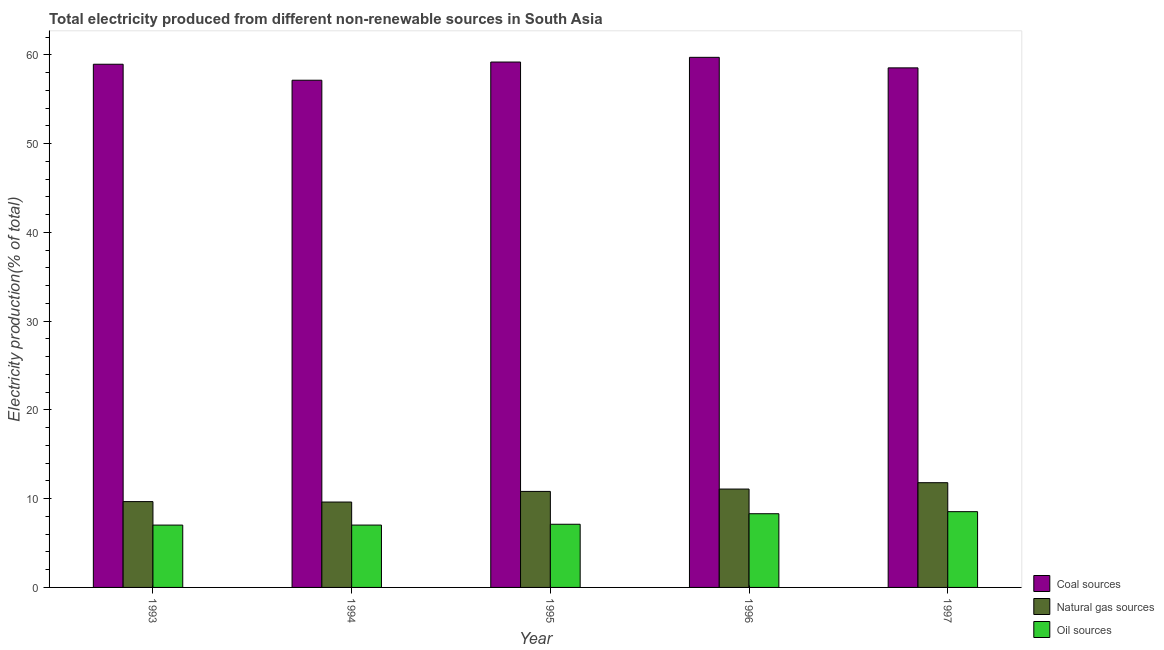Are the number of bars per tick equal to the number of legend labels?
Give a very brief answer. Yes. Are the number of bars on each tick of the X-axis equal?
Your answer should be compact. Yes. What is the label of the 3rd group of bars from the left?
Make the answer very short. 1995. In how many cases, is the number of bars for a given year not equal to the number of legend labels?
Make the answer very short. 0. What is the percentage of electricity produced by natural gas in 1996?
Your answer should be compact. 11.08. Across all years, what is the maximum percentage of electricity produced by coal?
Your answer should be compact. 59.73. Across all years, what is the minimum percentage of electricity produced by natural gas?
Ensure brevity in your answer.  9.62. In which year was the percentage of electricity produced by oil sources maximum?
Ensure brevity in your answer.  1997. What is the total percentage of electricity produced by natural gas in the graph?
Ensure brevity in your answer.  53. What is the difference between the percentage of electricity produced by natural gas in 1993 and that in 1995?
Provide a succinct answer. -1.15. What is the difference between the percentage of electricity produced by natural gas in 1996 and the percentage of electricity produced by coal in 1993?
Your answer should be very brief. 1.41. What is the average percentage of electricity produced by oil sources per year?
Offer a very short reply. 7.6. In how many years, is the percentage of electricity produced by oil sources greater than 44 %?
Your answer should be very brief. 0. What is the ratio of the percentage of electricity produced by oil sources in 1995 to that in 1997?
Give a very brief answer. 0.83. Is the percentage of electricity produced by coal in 1994 less than that in 1997?
Provide a succinct answer. Yes. What is the difference between the highest and the second highest percentage of electricity produced by coal?
Make the answer very short. 0.53. What is the difference between the highest and the lowest percentage of electricity produced by coal?
Make the answer very short. 2.58. Is the sum of the percentage of electricity produced by coal in 1994 and 1995 greater than the maximum percentage of electricity produced by natural gas across all years?
Your response must be concise. Yes. What does the 3rd bar from the left in 1997 represents?
Give a very brief answer. Oil sources. What does the 2nd bar from the right in 1994 represents?
Ensure brevity in your answer.  Natural gas sources. Is it the case that in every year, the sum of the percentage of electricity produced by coal and percentage of electricity produced by natural gas is greater than the percentage of electricity produced by oil sources?
Offer a very short reply. Yes. How many bars are there?
Your response must be concise. 15. Does the graph contain any zero values?
Give a very brief answer. No. Where does the legend appear in the graph?
Your answer should be compact. Bottom right. What is the title of the graph?
Your response must be concise. Total electricity produced from different non-renewable sources in South Asia. What is the label or title of the X-axis?
Offer a terse response. Year. What is the label or title of the Y-axis?
Provide a succinct answer. Electricity production(% of total). What is the Electricity production(% of total) in Coal sources in 1993?
Offer a very short reply. 58.95. What is the Electricity production(% of total) in Natural gas sources in 1993?
Keep it short and to the point. 9.67. What is the Electricity production(% of total) of Oil sources in 1993?
Your answer should be compact. 7.02. What is the Electricity production(% of total) of Coal sources in 1994?
Make the answer very short. 57.15. What is the Electricity production(% of total) of Natural gas sources in 1994?
Your answer should be very brief. 9.62. What is the Electricity production(% of total) in Oil sources in 1994?
Your response must be concise. 7.03. What is the Electricity production(% of total) of Coal sources in 1995?
Offer a terse response. 59.2. What is the Electricity production(% of total) in Natural gas sources in 1995?
Provide a short and direct response. 10.82. What is the Electricity production(% of total) of Oil sources in 1995?
Provide a succinct answer. 7.12. What is the Electricity production(% of total) of Coal sources in 1996?
Make the answer very short. 59.73. What is the Electricity production(% of total) of Natural gas sources in 1996?
Keep it short and to the point. 11.08. What is the Electricity production(% of total) of Oil sources in 1996?
Your answer should be compact. 8.3. What is the Electricity production(% of total) in Coal sources in 1997?
Your response must be concise. 58.55. What is the Electricity production(% of total) of Natural gas sources in 1997?
Your answer should be very brief. 11.8. What is the Electricity production(% of total) in Oil sources in 1997?
Provide a succinct answer. 8.54. Across all years, what is the maximum Electricity production(% of total) in Coal sources?
Your response must be concise. 59.73. Across all years, what is the maximum Electricity production(% of total) of Natural gas sources?
Give a very brief answer. 11.8. Across all years, what is the maximum Electricity production(% of total) of Oil sources?
Ensure brevity in your answer.  8.54. Across all years, what is the minimum Electricity production(% of total) in Coal sources?
Make the answer very short. 57.15. Across all years, what is the minimum Electricity production(% of total) of Natural gas sources?
Make the answer very short. 9.62. Across all years, what is the minimum Electricity production(% of total) in Oil sources?
Provide a succinct answer. 7.02. What is the total Electricity production(% of total) of Coal sources in the graph?
Provide a short and direct response. 293.59. What is the total Electricity production(% of total) in Natural gas sources in the graph?
Make the answer very short. 53. What is the total Electricity production(% of total) of Oil sources in the graph?
Offer a very short reply. 38.01. What is the difference between the Electricity production(% of total) of Coal sources in 1993 and that in 1994?
Ensure brevity in your answer.  1.8. What is the difference between the Electricity production(% of total) in Natural gas sources in 1993 and that in 1994?
Give a very brief answer. 0.05. What is the difference between the Electricity production(% of total) in Oil sources in 1993 and that in 1994?
Provide a short and direct response. -0. What is the difference between the Electricity production(% of total) of Coal sources in 1993 and that in 1995?
Provide a short and direct response. -0.25. What is the difference between the Electricity production(% of total) of Natural gas sources in 1993 and that in 1995?
Make the answer very short. -1.15. What is the difference between the Electricity production(% of total) of Oil sources in 1993 and that in 1995?
Provide a succinct answer. -0.09. What is the difference between the Electricity production(% of total) of Coal sources in 1993 and that in 1996?
Your response must be concise. -0.78. What is the difference between the Electricity production(% of total) of Natural gas sources in 1993 and that in 1996?
Your response must be concise. -1.41. What is the difference between the Electricity production(% of total) of Oil sources in 1993 and that in 1996?
Your response must be concise. -1.28. What is the difference between the Electricity production(% of total) of Coal sources in 1993 and that in 1997?
Provide a short and direct response. 0.41. What is the difference between the Electricity production(% of total) of Natural gas sources in 1993 and that in 1997?
Keep it short and to the point. -2.13. What is the difference between the Electricity production(% of total) in Oil sources in 1993 and that in 1997?
Your answer should be very brief. -1.51. What is the difference between the Electricity production(% of total) of Coal sources in 1994 and that in 1995?
Your answer should be very brief. -2.05. What is the difference between the Electricity production(% of total) of Natural gas sources in 1994 and that in 1995?
Offer a very short reply. -1.2. What is the difference between the Electricity production(% of total) of Oil sources in 1994 and that in 1995?
Ensure brevity in your answer.  -0.09. What is the difference between the Electricity production(% of total) in Coal sources in 1994 and that in 1996?
Provide a succinct answer. -2.58. What is the difference between the Electricity production(% of total) of Natural gas sources in 1994 and that in 1996?
Ensure brevity in your answer.  -1.46. What is the difference between the Electricity production(% of total) in Oil sources in 1994 and that in 1996?
Ensure brevity in your answer.  -1.28. What is the difference between the Electricity production(% of total) in Coal sources in 1994 and that in 1997?
Offer a very short reply. -1.39. What is the difference between the Electricity production(% of total) in Natural gas sources in 1994 and that in 1997?
Make the answer very short. -2.18. What is the difference between the Electricity production(% of total) in Oil sources in 1994 and that in 1997?
Offer a terse response. -1.51. What is the difference between the Electricity production(% of total) of Coal sources in 1995 and that in 1996?
Give a very brief answer. -0.53. What is the difference between the Electricity production(% of total) of Natural gas sources in 1995 and that in 1996?
Give a very brief answer. -0.27. What is the difference between the Electricity production(% of total) in Oil sources in 1995 and that in 1996?
Give a very brief answer. -1.19. What is the difference between the Electricity production(% of total) of Coal sources in 1995 and that in 1997?
Offer a very short reply. 0.66. What is the difference between the Electricity production(% of total) in Natural gas sources in 1995 and that in 1997?
Offer a very short reply. -0.98. What is the difference between the Electricity production(% of total) in Oil sources in 1995 and that in 1997?
Keep it short and to the point. -1.42. What is the difference between the Electricity production(% of total) in Coal sources in 1996 and that in 1997?
Provide a short and direct response. 1.19. What is the difference between the Electricity production(% of total) of Natural gas sources in 1996 and that in 1997?
Offer a terse response. -0.72. What is the difference between the Electricity production(% of total) in Oil sources in 1996 and that in 1997?
Make the answer very short. -0.23. What is the difference between the Electricity production(% of total) of Coal sources in 1993 and the Electricity production(% of total) of Natural gas sources in 1994?
Your answer should be very brief. 49.33. What is the difference between the Electricity production(% of total) in Coal sources in 1993 and the Electricity production(% of total) in Oil sources in 1994?
Your response must be concise. 51.93. What is the difference between the Electricity production(% of total) in Natural gas sources in 1993 and the Electricity production(% of total) in Oil sources in 1994?
Offer a terse response. 2.64. What is the difference between the Electricity production(% of total) of Coal sources in 1993 and the Electricity production(% of total) of Natural gas sources in 1995?
Offer a very short reply. 48.14. What is the difference between the Electricity production(% of total) in Coal sources in 1993 and the Electricity production(% of total) in Oil sources in 1995?
Keep it short and to the point. 51.84. What is the difference between the Electricity production(% of total) in Natural gas sources in 1993 and the Electricity production(% of total) in Oil sources in 1995?
Offer a terse response. 2.55. What is the difference between the Electricity production(% of total) of Coal sources in 1993 and the Electricity production(% of total) of Natural gas sources in 1996?
Provide a succinct answer. 47.87. What is the difference between the Electricity production(% of total) in Coal sources in 1993 and the Electricity production(% of total) in Oil sources in 1996?
Your response must be concise. 50.65. What is the difference between the Electricity production(% of total) in Natural gas sources in 1993 and the Electricity production(% of total) in Oil sources in 1996?
Your response must be concise. 1.37. What is the difference between the Electricity production(% of total) in Coal sources in 1993 and the Electricity production(% of total) in Natural gas sources in 1997?
Ensure brevity in your answer.  47.15. What is the difference between the Electricity production(% of total) in Coal sources in 1993 and the Electricity production(% of total) in Oil sources in 1997?
Give a very brief answer. 50.42. What is the difference between the Electricity production(% of total) in Natural gas sources in 1993 and the Electricity production(% of total) in Oil sources in 1997?
Make the answer very short. 1.13. What is the difference between the Electricity production(% of total) in Coal sources in 1994 and the Electricity production(% of total) in Natural gas sources in 1995?
Give a very brief answer. 46.33. What is the difference between the Electricity production(% of total) of Coal sources in 1994 and the Electricity production(% of total) of Oil sources in 1995?
Keep it short and to the point. 50.03. What is the difference between the Electricity production(% of total) in Natural gas sources in 1994 and the Electricity production(% of total) in Oil sources in 1995?
Your answer should be very brief. 2.5. What is the difference between the Electricity production(% of total) in Coal sources in 1994 and the Electricity production(% of total) in Natural gas sources in 1996?
Provide a short and direct response. 46.07. What is the difference between the Electricity production(% of total) of Coal sources in 1994 and the Electricity production(% of total) of Oil sources in 1996?
Offer a very short reply. 48.85. What is the difference between the Electricity production(% of total) of Natural gas sources in 1994 and the Electricity production(% of total) of Oil sources in 1996?
Your answer should be compact. 1.32. What is the difference between the Electricity production(% of total) in Coal sources in 1994 and the Electricity production(% of total) in Natural gas sources in 1997?
Offer a terse response. 45.35. What is the difference between the Electricity production(% of total) in Coal sources in 1994 and the Electricity production(% of total) in Oil sources in 1997?
Offer a terse response. 48.62. What is the difference between the Electricity production(% of total) in Natural gas sources in 1994 and the Electricity production(% of total) in Oil sources in 1997?
Offer a terse response. 1.09. What is the difference between the Electricity production(% of total) in Coal sources in 1995 and the Electricity production(% of total) in Natural gas sources in 1996?
Your answer should be very brief. 48.12. What is the difference between the Electricity production(% of total) of Coal sources in 1995 and the Electricity production(% of total) of Oil sources in 1996?
Your response must be concise. 50.9. What is the difference between the Electricity production(% of total) in Natural gas sources in 1995 and the Electricity production(% of total) in Oil sources in 1996?
Make the answer very short. 2.51. What is the difference between the Electricity production(% of total) of Coal sources in 1995 and the Electricity production(% of total) of Natural gas sources in 1997?
Give a very brief answer. 47.4. What is the difference between the Electricity production(% of total) in Coal sources in 1995 and the Electricity production(% of total) in Oil sources in 1997?
Ensure brevity in your answer.  50.67. What is the difference between the Electricity production(% of total) of Natural gas sources in 1995 and the Electricity production(% of total) of Oil sources in 1997?
Make the answer very short. 2.28. What is the difference between the Electricity production(% of total) in Coal sources in 1996 and the Electricity production(% of total) in Natural gas sources in 1997?
Provide a short and direct response. 47.93. What is the difference between the Electricity production(% of total) of Coal sources in 1996 and the Electricity production(% of total) of Oil sources in 1997?
Give a very brief answer. 51.2. What is the difference between the Electricity production(% of total) in Natural gas sources in 1996 and the Electricity production(% of total) in Oil sources in 1997?
Make the answer very short. 2.55. What is the average Electricity production(% of total) in Coal sources per year?
Your answer should be very brief. 58.72. What is the average Electricity production(% of total) of Natural gas sources per year?
Your answer should be very brief. 10.6. What is the average Electricity production(% of total) of Oil sources per year?
Give a very brief answer. 7.6. In the year 1993, what is the difference between the Electricity production(% of total) of Coal sources and Electricity production(% of total) of Natural gas sources?
Your answer should be compact. 49.28. In the year 1993, what is the difference between the Electricity production(% of total) of Coal sources and Electricity production(% of total) of Oil sources?
Keep it short and to the point. 51.93. In the year 1993, what is the difference between the Electricity production(% of total) in Natural gas sources and Electricity production(% of total) in Oil sources?
Offer a terse response. 2.65. In the year 1994, what is the difference between the Electricity production(% of total) of Coal sources and Electricity production(% of total) of Natural gas sources?
Keep it short and to the point. 47.53. In the year 1994, what is the difference between the Electricity production(% of total) in Coal sources and Electricity production(% of total) in Oil sources?
Offer a terse response. 50.13. In the year 1994, what is the difference between the Electricity production(% of total) in Natural gas sources and Electricity production(% of total) in Oil sources?
Offer a terse response. 2.6. In the year 1995, what is the difference between the Electricity production(% of total) in Coal sources and Electricity production(% of total) in Natural gas sources?
Offer a very short reply. 48.38. In the year 1995, what is the difference between the Electricity production(% of total) of Coal sources and Electricity production(% of total) of Oil sources?
Provide a succinct answer. 52.08. In the year 1995, what is the difference between the Electricity production(% of total) in Natural gas sources and Electricity production(% of total) in Oil sources?
Provide a succinct answer. 3.7. In the year 1996, what is the difference between the Electricity production(% of total) in Coal sources and Electricity production(% of total) in Natural gas sources?
Provide a succinct answer. 48.65. In the year 1996, what is the difference between the Electricity production(% of total) of Coal sources and Electricity production(% of total) of Oil sources?
Ensure brevity in your answer.  51.43. In the year 1996, what is the difference between the Electricity production(% of total) of Natural gas sources and Electricity production(% of total) of Oil sources?
Your answer should be compact. 2.78. In the year 1997, what is the difference between the Electricity production(% of total) of Coal sources and Electricity production(% of total) of Natural gas sources?
Give a very brief answer. 46.75. In the year 1997, what is the difference between the Electricity production(% of total) of Coal sources and Electricity production(% of total) of Oil sources?
Provide a succinct answer. 50.01. In the year 1997, what is the difference between the Electricity production(% of total) of Natural gas sources and Electricity production(% of total) of Oil sources?
Keep it short and to the point. 3.26. What is the ratio of the Electricity production(% of total) of Coal sources in 1993 to that in 1994?
Your answer should be very brief. 1.03. What is the ratio of the Electricity production(% of total) of Natural gas sources in 1993 to that in 1994?
Provide a succinct answer. 1. What is the ratio of the Electricity production(% of total) of Oil sources in 1993 to that in 1994?
Your response must be concise. 1. What is the ratio of the Electricity production(% of total) in Coal sources in 1993 to that in 1995?
Your answer should be very brief. 1. What is the ratio of the Electricity production(% of total) of Natural gas sources in 1993 to that in 1995?
Your answer should be compact. 0.89. What is the ratio of the Electricity production(% of total) of Oil sources in 1993 to that in 1995?
Give a very brief answer. 0.99. What is the ratio of the Electricity production(% of total) in Natural gas sources in 1993 to that in 1996?
Provide a succinct answer. 0.87. What is the ratio of the Electricity production(% of total) in Oil sources in 1993 to that in 1996?
Provide a short and direct response. 0.85. What is the ratio of the Electricity production(% of total) in Coal sources in 1993 to that in 1997?
Your response must be concise. 1.01. What is the ratio of the Electricity production(% of total) of Natural gas sources in 1993 to that in 1997?
Offer a terse response. 0.82. What is the ratio of the Electricity production(% of total) in Oil sources in 1993 to that in 1997?
Your answer should be very brief. 0.82. What is the ratio of the Electricity production(% of total) in Coal sources in 1994 to that in 1995?
Ensure brevity in your answer.  0.97. What is the ratio of the Electricity production(% of total) of Natural gas sources in 1994 to that in 1995?
Keep it short and to the point. 0.89. What is the ratio of the Electricity production(% of total) of Oil sources in 1994 to that in 1995?
Provide a short and direct response. 0.99. What is the ratio of the Electricity production(% of total) of Coal sources in 1994 to that in 1996?
Keep it short and to the point. 0.96. What is the ratio of the Electricity production(% of total) of Natural gas sources in 1994 to that in 1996?
Your response must be concise. 0.87. What is the ratio of the Electricity production(% of total) of Oil sources in 1994 to that in 1996?
Your answer should be compact. 0.85. What is the ratio of the Electricity production(% of total) in Coal sources in 1994 to that in 1997?
Provide a short and direct response. 0.98. What is the ratio of the Electricity production(% of total) in Natural gas sources in 1994 to that in 1997?
Provide a succinct answer. 0.82. What is the ratio of the Electricity production(% of total) of Oil sources in 1994 to that in 1997?
Provide a succinct answer. 0.82. What is the ratio of the Electricity production(% of total) in Natural gas sources in 1995 to that in 1996?
Your answer should be very brief. 0.98. What is the ratio of the Electricity production(% of total) of Oil sources in 1995 to that in 1996?
Your answer should be very brief. 0.86. What is the ratio of the Electricity production(% of total) in Coal sources in 1995 to that in 1997?
Your answer should be very brief. 1.01. What is the ratio of the Electricity production(% of total) of Natural gas sources in 1995 to that in 1997?
Make the answer very short. 0.92. What is the ratio of the Electricity production(% of total) in Oil sources in 1995 to that in 1997?
Make the answer very short. 0.83. What is the ratio of the Electricity production(% of total) of Coal sources in 1996 to that in 1997?
Provide a succinct answer. 1.02. What is the ratio of the Electricity production(% of total) in Natural gas sources in 1996 to that in 1997?
Your answer should be compact. 0.94. What is the ratio of the Electricity production(% of total) of Oil sources in 1996 to that in 1997?
Your answer should be very brief. 0.97. What is the difference between the highest and the second highest Electricity production(% of total) of Coal sources?
Your answer should be very brief. 0.53. What is the difference between the highest and the second highest Electricity production(% of total) of Natural gas sources?
Offer a terse response. 0.72. What is the difference between the highest and the second highest Electricity production(% of total) in Oil sources?
Your answer should be very brief. 0.23. What is the difference between the highest and the lowest Electricity production(% of total) of Coal sources?
Provide a succinct answer. 2.58. What is the difference between the highest and the lowest Electricity production(% of total) of Natural gas sources?
Provide a succinct answer. 2.18. What is the difference between the highest and the lowest Electricity production(% of total) in Oil sources?
Your response must be concise. 1.51. 